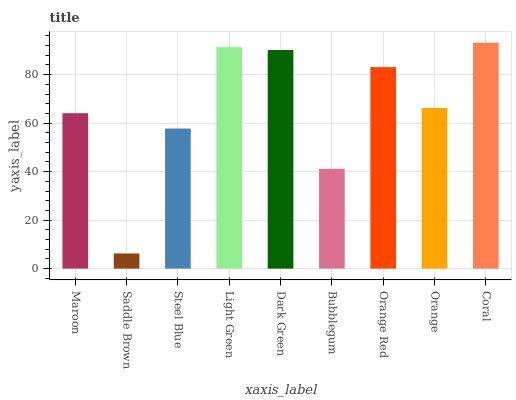Is Steel Blue the minimum?
Answer yes or no. No. Is Steel Blue the maximum?
Answer yes or no. No. Is Steel Blue greater than Saddle Brown?
Answer yes or no. Yes. Is Saddle Brown less than Steel Blue?
Answer yes or no. Yes. Is Saddle Brown greater than Steel Blue?
Answer yes or no. No. Is Steel Blue less than Saddle Brown?
Answer yes or no. No. Is Orange the high median?
Answer yes or no. Yes. Is Orange the low median?
Answer yes or no. Yes. Is Orange Red the high median?
Answer yes or no. No. Is Bubblegum the low median?
Answer yes or no. No. 